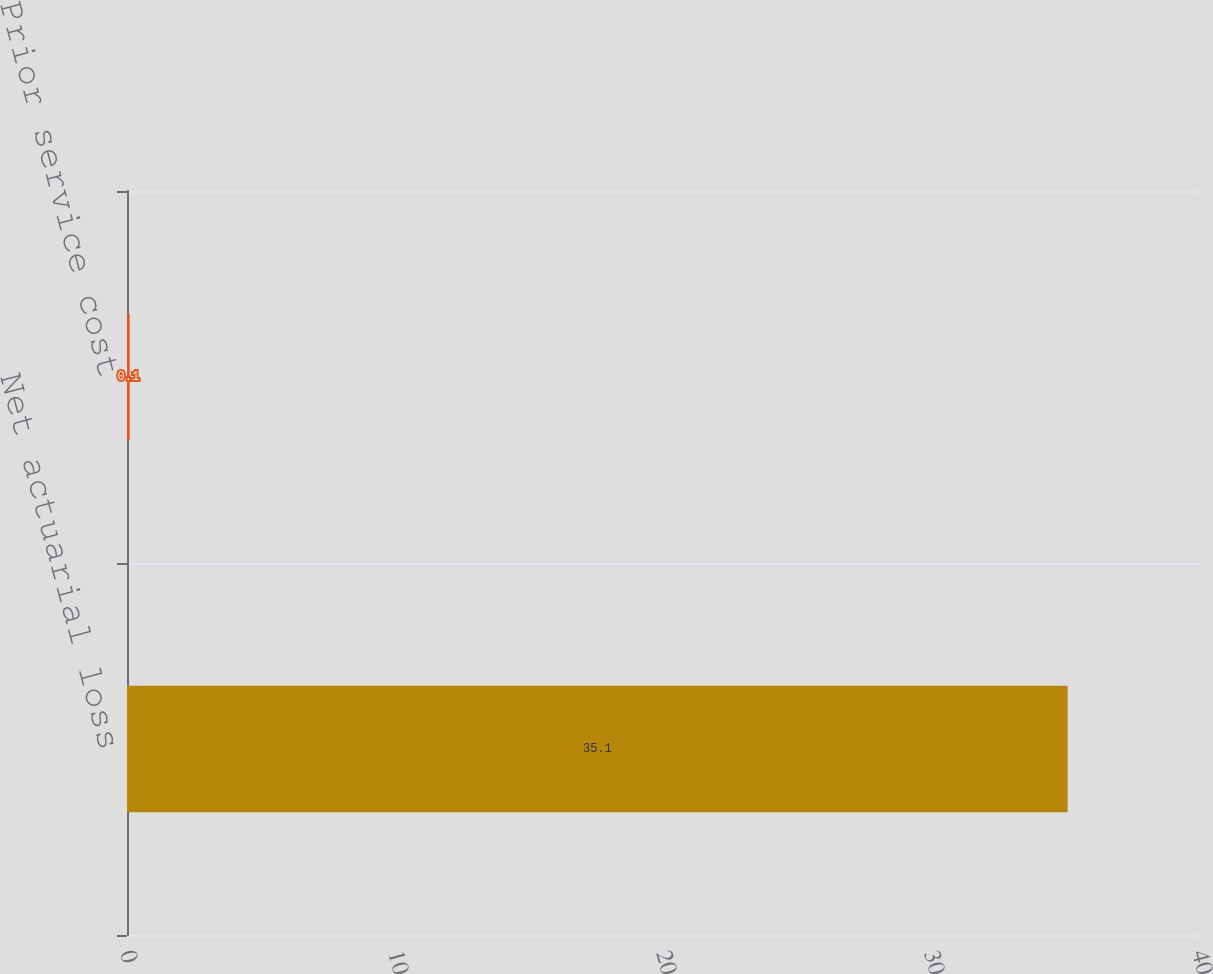Convert chart to OTSL. <chart><loc_0><loc_0><loc_500><loc_500><bar_chart><fcel>Net actuarial loss<fcel>Prior service cost<nl><fcel>35.1<fcel>0.1<nl></chart> 